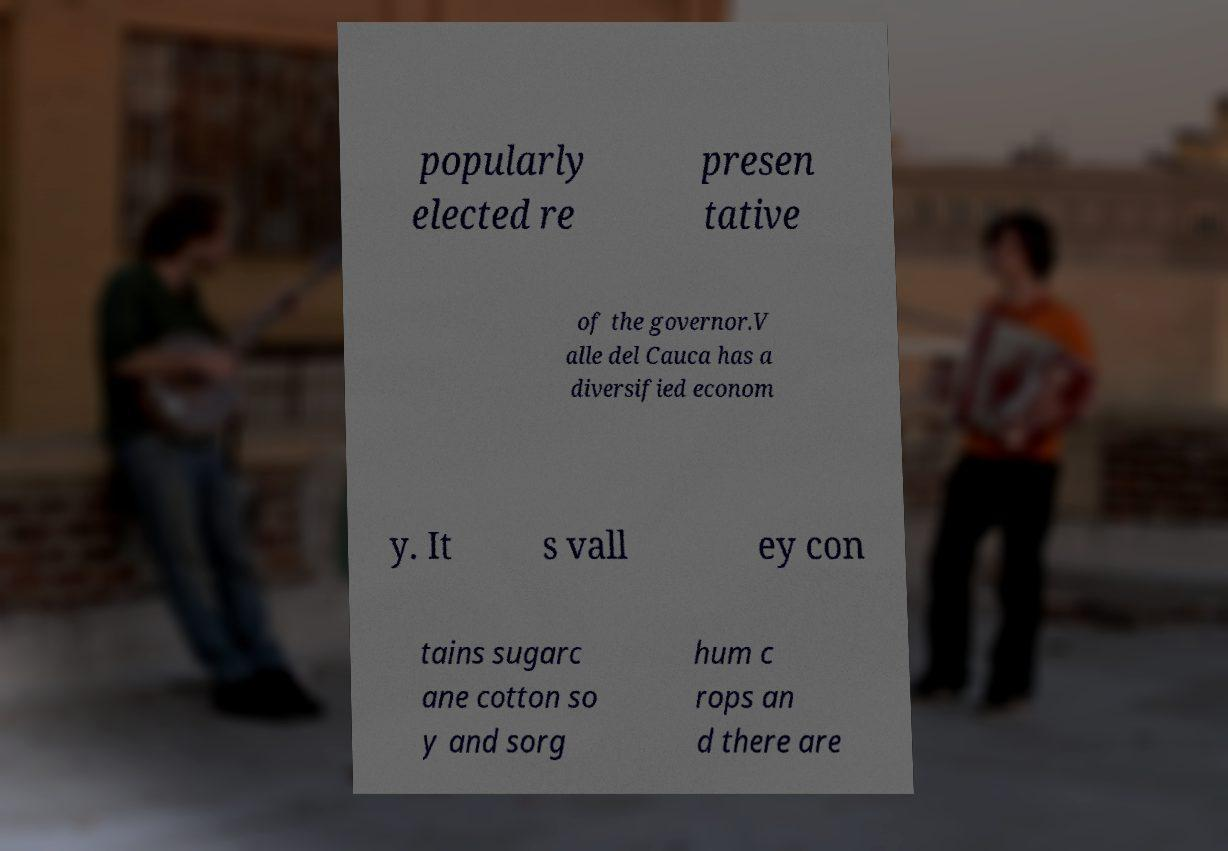Could you extract and type out the text from this image? popularly elected re presen tative of the governor.V alle del Cauca has a diversified econom y. It s vall ey con tains sugarc ane cotton so y and sorg hum c rops an d there are 